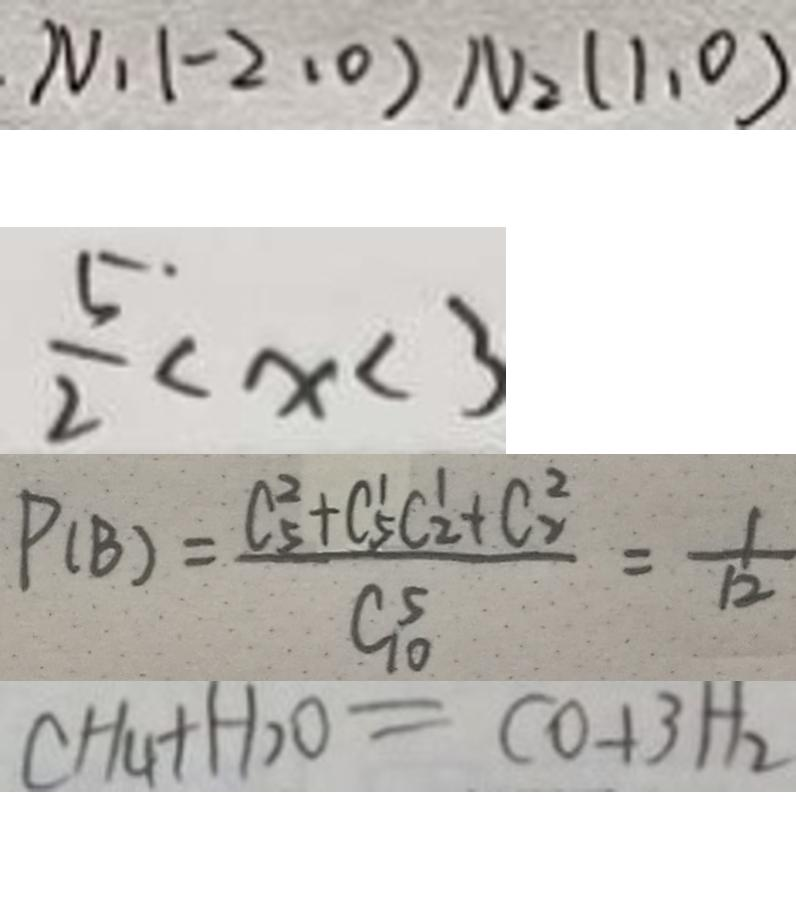<formula> <loc_0><loc_0><loc_500><loc_500>N _ { 1 } ( - 2 , 0 ) N _ { 2 } ( 1 , 0 ) 
 \frac { 5 } { 2 } < x < 3 
 P ( B ) = \frac { C _ { 5 } ^ { 2 } + C _ { 5 } ^ { \prime } C _ { 2 } ^ { \prime } + C _ { 2 } ^ { 2 } } { C _ { 1 0 } ^ { 5 } } = \frac { 1 } { 1 2 } 
 C H _ { 4 } + H _ { 2 } O = C O + 3 H _ { 2 }</formula> 